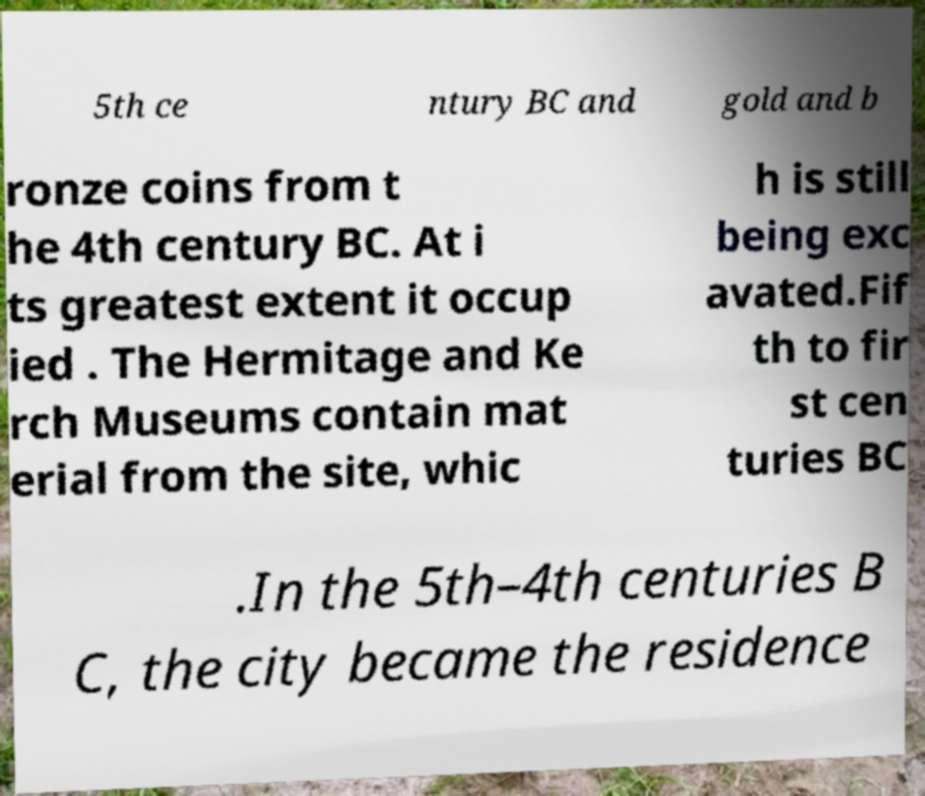There's text embedded in this image that I need extracted. Can you transcribe it verbatim? 5th ce ntury BC and gold and b ronze coins from t he 4th century BC. At i ts greatest extent it occup ied . The Hermitage and Ke rch Museums contain mat erial from the site, whic h is still being exc avated.Fif th to fir st cen turies BC .In the 5th–4th centuries B C, the city became the residence 